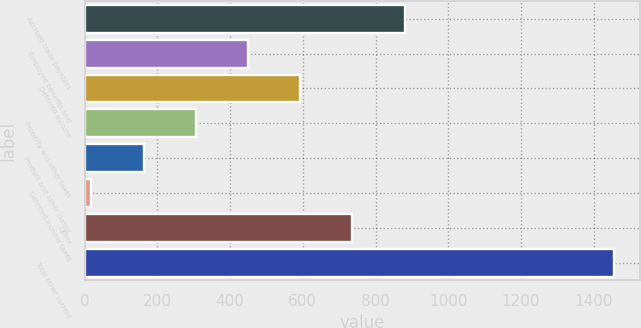<chart> <loc_0><loc_0><loc_500><loc_500><bar_chart><fcel>Accrued trade payables<fcel>Employee benefits and<fcel>Deferred income<fcel>Property and other taxes<fcel>Product and other claims<fcel>Deferred income taxes<fcel>Other<fcel>Total other current<nl><fcel>880.2<fcel>449.1<fcel>592.8<fcel>305.4<fcel>161.7<fcel>18<fcel>736.5<fcel>1455<nl></chart> 